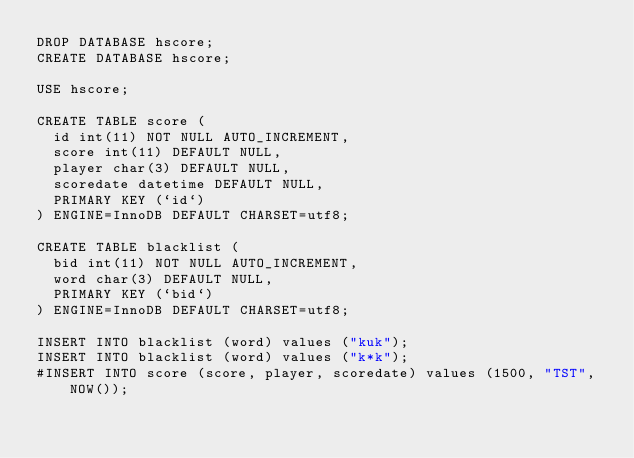Convert code to text. <code><loc_0><loc_0><loc_500><loc_500><_SQL_>DROP DATABASE hscore;
CREATE DATABASE hscore;

USE hscore;

CREATE TABLE score (
  id int(11) NOT NULL AUTO_INCREMENT,
  score int(11) DEFAULT NULL,
  player char(3) DEFAULT NULL,
  scoredate datetime DEFAULT NULL,
  PRIMARY KEY (`id`)
) ENGINE=InnoDB DEFAULT CHARSET=utf8;

CREATE TABLE blacklist (
  bid int(11) NOT NULL AUTO_INCREMENT,
  word char(3) DEFAULT NULL,
  PRIMARY KEY (`bid`)
) ENGINE=InnoDB DEFAULT CHARSET=utf8;

INSERT INTO blacklist (word) values ("kuk");
INSERT INTO blacklist (word) values ("k*k");
#INSERT INTO score (score, player, scoredate) values (1500, "TST", NOW());

</code> 